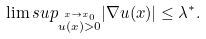Convert formula to latex. <formula><loc_0><loc_0><loc_500><loc_500>& \lim s u p _ { \stackrel { x \to x _ { 0 } } { u ( x ) > 0 } } | \nabla u ( x ) | \leq \lambda ^ { * } .</formula> 